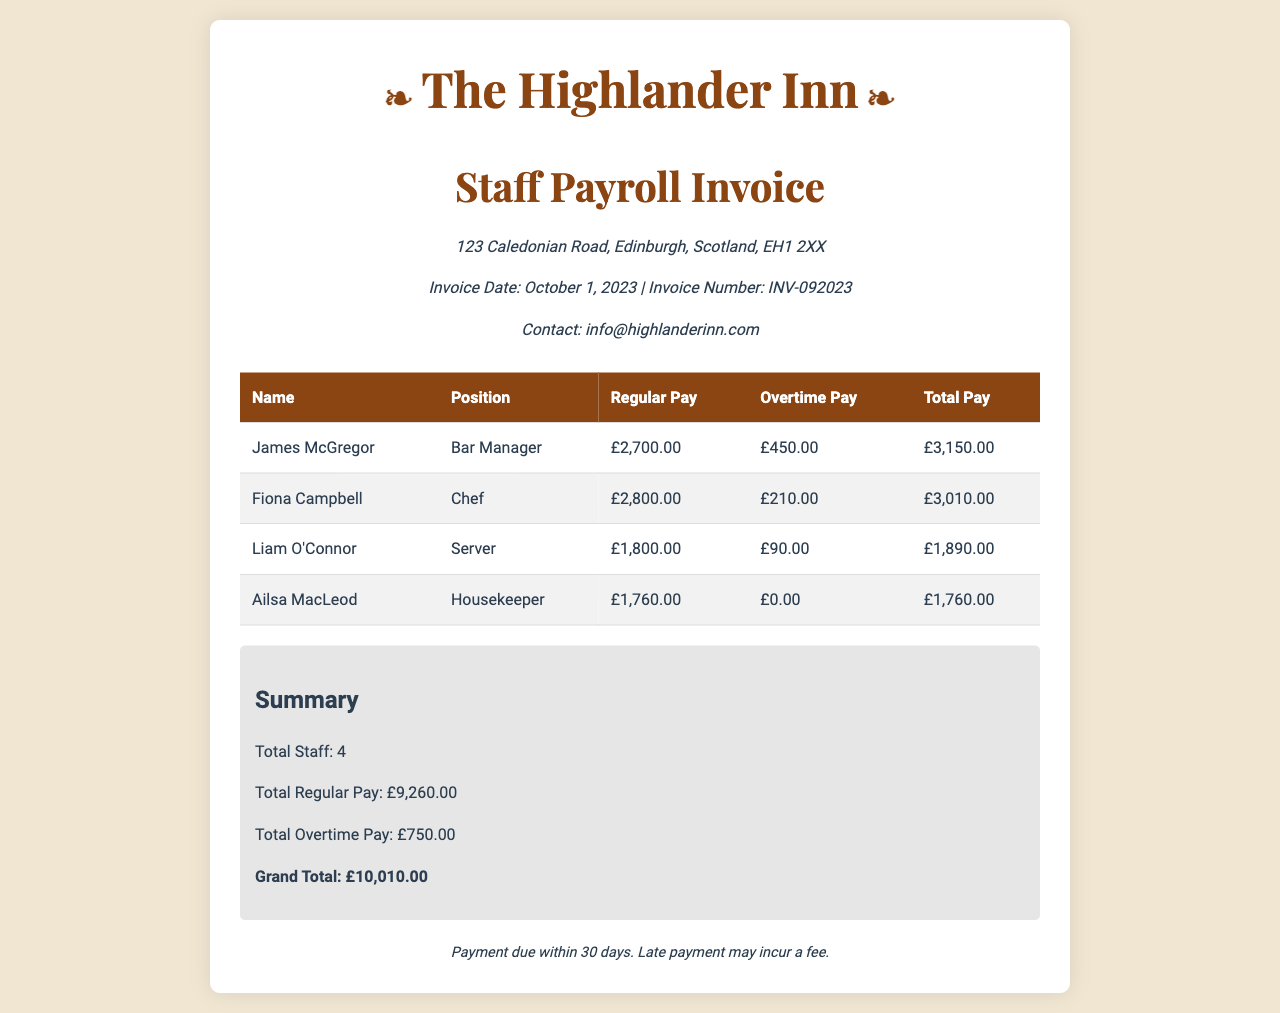What is the invoice number? The invoice number is specified in the header of the document to identify the invoice uniquely.
Answer: INV-092023 What is the total regular pay for all staff? The total regular pay is the sum of each staff member's regular pay listed in the table.
Answer: £9,260.00 Who is the Bar Manager? The position of Bar Manager is listed along with the corresponding staff member's name in the table.
Answer: James McGregor What is the total overtime pay? The total overtime pay is calculated by adding each staff member's overtime pay.
Answer: £750.00 What is Ailsa MacLeod's total pay? Ailsa MacLeod's total pay is found in the last column of her row in the staff payroll table.
Answer: £1,760.00 How many staff members are listed on the invoice? The total number of staff members can be found in the summary section.
Answer: 4 What is the grand total on the invoice? The grand total is the final amount listed in the summary section, representing the overall payroll.
Answer: £10,010.00 When is the payment due by? The payment terms indicate the expected payment timeframe outlined in the document.
Answer: 30 days What is the position of Fiona Campbell? This position is clearly listed next to Fiona Campbell's name in the staff payroll table.
Answer: Chef 